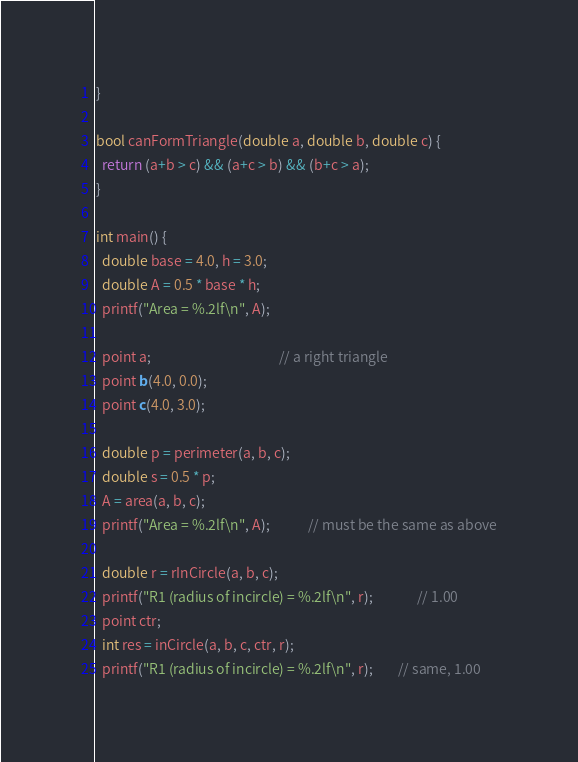Convert code to text. <code><loc_0><loc_0><loc_500><loc_500><_C++_>}

bool canFormTriangle(double a, double b, double c) {
  return (a+b > c) && (a+c > b) && (b+c > a);
}

int main() {
  double base = 4.0, h = 3.0;
  double A = 0.5 * base * h;
  printf("Area = %.2lf\n", A);

  point a;                                         // a right triangle
  point b(4.0, 0.0);
  point c(4.0, 3.0);

  double p = perimeter(a, b, c);
  double s = 0.5 * p;
  A = area(a, b, c);
  printf("Area = %.2lf\n", A);            // must be the same as above

  double r = rInCircle(a, b, c);
  printf("R1 (radius of incircle) = %.2lf\n", r);              // 1.00
  point ctr;
  int res = inCircle(a, b, c, ctr, r);
  printf("R1 (radius of incircle) = %.2lf\n", r);        // same, 1.00</code> 